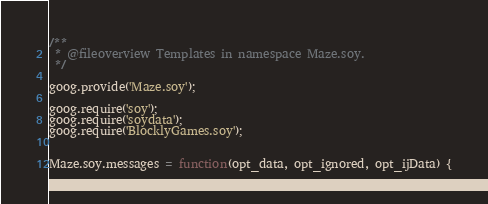Convert code to text. <code><loc_0><loc_0><loc_500><loc_500><_JavaScript_>/**
 * @fileoverview Templates in namespace Maze.soy.
 */

goog.provide('Maze.soy');

goog.require('soy');
goog.require('soydata');
goog.require('BlocklyGames.soy');


Maze.soy.messages = function(opt_data, opt_ignored, opt_ijData) {</code> 